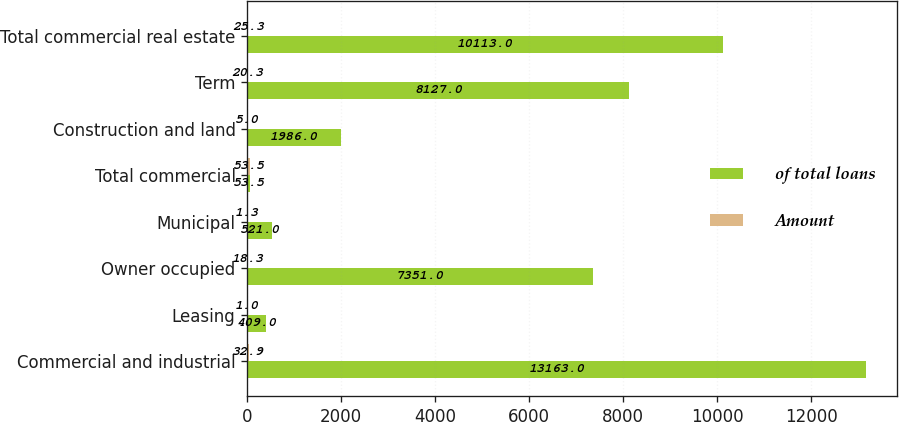Convert chart to OTSL. <chart><loc_0><loc_0><loc_500><loc_500><stacked_bar_chart><ecel><fcel>Commercial and industrial<fcel>Leasing<fcel>Owner occupied<fcel>Municipal<fcel>Total commercial<fcel>Construction and land<fcel>Term<fcel>Total commercial real estate<nl><fcel>of total loans<fcel>13163<fcel>409<fcel>7351<fcel>521<fcel>53.5<fcel>1986<fcel>8127<fcel>10113<nl><fcel>Amount<fcel>32.9<fcel>1<fcel>18.3<fcel>1.3<fcel>53.5<fcel>5<fcel>20.3<fcel>25.3<nl></chart> 